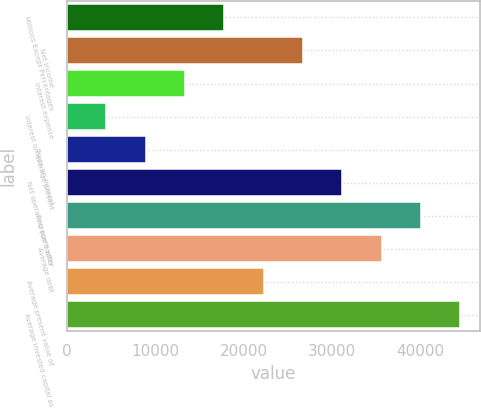Convert chart. <chart><loc_0><loc_0><loc_500><loc_500><bar_chart><fcel>Millions Except Percentages<fcel>Net income<fcel>Interest expense<fcel>Interest on average present<fcel>Taxes on interest<fcel>Net operating profit after<fcel>Average equity<fcel>Average debt<fcel>Average present value of<fcel>Average invested capital as<nl><fcel>17814.7<fcel>26714.4<fcel>13364.8<fcel>4464.99<fcel>8914.88<fcel>31164.3<fcel>40064.1<fcel>35614.2<fcel>22264.5<fcel>44514<nl></chart> 